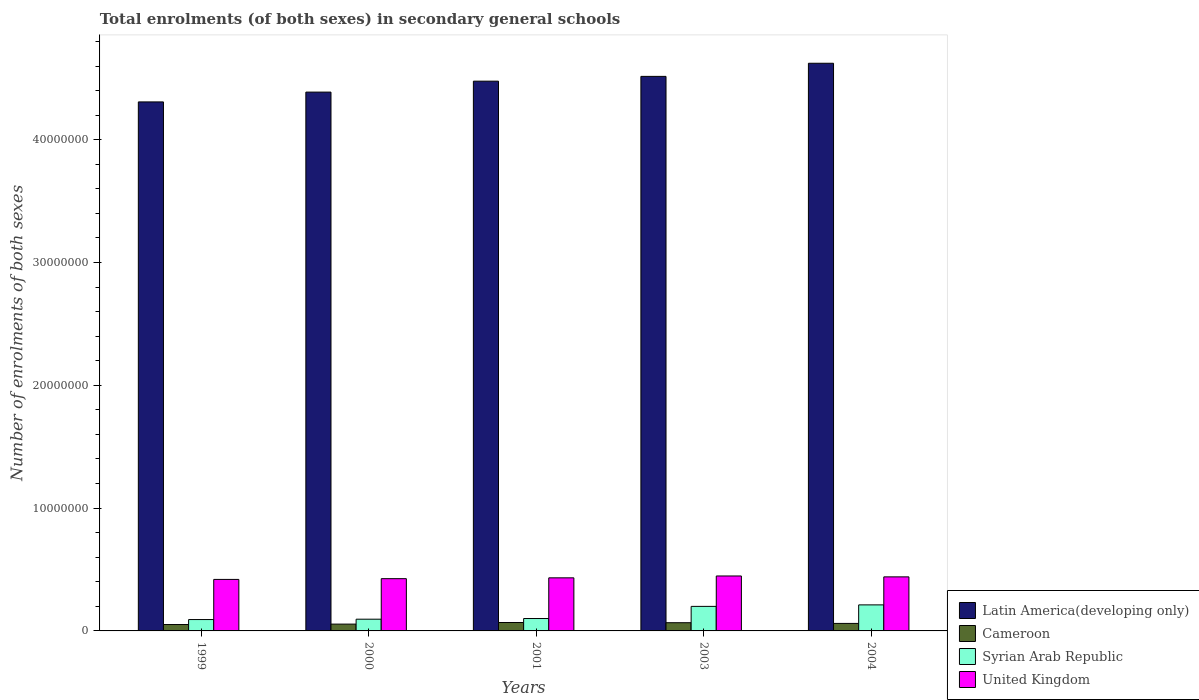How many different coloured bars are there?
Provide a succinct answer. 4. How many groups of bars are there?
Your answer should be compact. 5. Are the number of bars on each tick of the X-axis equal?
Make the answer very short. Yes. How many bars are there on the 3rd tick from the left?
Your response must be concise. 4. How many bars are there on the 2nd tick from the right?
Give a very brief answer. 4. What is the label of the 5th group of bars from the left?
Give a very brief answer. 2004. What is the number of enrolments in secondary schools in Latin America(developing only) in 2000?
Provide a succinct answer. 4.39e+07. Across all years, what is the maximum number of enrolments in secondary schools in Latin America(developing only)?
Offer a very short reply. 4.62e+07. Across all years, what is the minimum number of enrolments in secondary schools in United Kingdom?
Offer a very short reply. 4.19e+06. In which year was the number of enrolments in secondary schools in United Kingdom maximum?
Offer a very short reply. 2003. What is the total number of enrolments in secondary schools in Latin America(developing only) in the graph?
Keep it short and to the point. 2.23e+08. What is the difference between the number of enrolments in secondary schools in Syrian Arab Republic in 2001 and that in 2003?
Your answer should be compact. -9.88e+05. What is the difference between the number of enrolments in secondary schools in Cameroon in 2001 and the number of enrolments in secondary schools in United Kingdom in 2004?
Keep it short and to the point. -3.72e+06. What is the average number of enrolments in secondary schools in Syrian Arab Republic per year?
Your response must be concise. 1.40e+06. In the year 2004, what is the difference between the number of enrolments in secondary schools in Latin America(developing only) and number of enrolments in secondary schools in Syrian Arab Republic?
Offer a terse response. 4.41e+07. What is the ratio of the number of enrolments in secondary schools in Cameroon in 2001 to that in 2003?
Offer a very short reply. 1.02. Is the number of enrolments in secondary schools in Latin America(developing only) in 1999 less than that in 2004?
Give a very brief answer. Yes. What is the difference between the highest and the second highest number of enrolments in secondary schools in Cameroon?
Your answer should be very brief. 1.55e+04. What is the difference between the highest and the lowest number of enrolments in secondary schools in Latin America(developing only)?
Provide a short and direct response. 3.15e+06. What does the 2nd bar from the left in 2004 represents?
Give a very brief answer. Cameroon. What does the 3rd bar from the right in 2000 represents?
Ensure brevity in your answer.  Cameroon. Is it the case that in every year, the sum of the number of enrolments in secondary schools in Latin America(developing only) and number of enrolments in secondary schools in Syrian Arab Republic is greater than the number of enrolments in secondary schools in United Kingdom?
Ensure brevity in your answer.  Yes. How many bars are there?
Offer a very short reply. 20. How many years are there in the graph?
Offer a terse response. 5. What is the difference between two consecutive major ticks on the Y-axis?
Give a very brief answer. 1.00e+07. Are the values on the major ticks of Y-axis written in scientific E-notation?
Provide a short and direct response. No. Does the graph contain any zero values?
Offer a very short reply. No. Does the graph contain grids?
Keep it short and to the point. No. Where does the legend appear in the graph?
Provide a short and direct response. Bottom right. What is the title of the graph?
Make the answer very short. Total enrolments (of both sexes) in secondary general schools. What is the label or title of the X-axis?
Make the answer very short. Years. What is the label or title of the Y-axis?
Your answer should be very brief. Number of enrolments of both sexes. What is the Number of enrolments of both sexes in Latin America(developing only) in 1999?
Give a very brief answer. 4.31e+07. What is the Number of enrolments of both sexes of Cameroon in 1999?
Your answer should be very brief. 5.21e+05. What is the Number of enrolments of both sexes of Syrian Arab Republic in 1999?
Offer a terse response. 9.25e+05. What is the Number of enrolments of both sexes in United Kingdom in 1999?
Give a very brief answer. 4.19e+06. What is the Number of enrolments of both sexes of Latin America(developing only) in 2000?
Your response must be concise. 4.39e+07. What is the Number of enrolments of both sexes of Cameroon in 2000?
Offer a very short reply. 5.55e+05. What is the Number of enrolments of both sexes in Syrian Arab Republic in 2000?
Provide a succinct answer. 9.55e+05. What is the Number of enrolments of both sexes in United Kingdom in 2000?
Your response must be concise. 4.26e+06. What is the Number of enrolments of both sexes in Latin America(developing only) in 2001?
Your answer should be very brief. 4.48e+07. What is the Number of enrolments of both sexes of Cameroon in 2001?
Ensure brevity in your answer.  6.85e+05. What is the Number of enrolments of both sexes in Syrian Arab Republic in 2001?
Your answer should be compact. 1.01e+06. What is the Number of enrolments of both sexes in United Kingdom in 2001?
Provide a short and direct response. 4.32e+06. What is the Number of enrolments of both sexes in Latin America(developing only) in 2003?
Ensure brevity in your answer.  4.52e+07. What is the Number of enrolments of both sexes in Cameroon in 2003?
Provide a short and direct response. 6.69e+05. What is the Number of enrolments of both sexes in Syrian Arab Republic in 2003?
Keep it short and to the point. 2.00e+06. What is the Number of enrolments of both sexes of United Kingdom in 2003?
Your answer should be compact. 4.47e+06. What is the Number of enrolments of both sexes of Latin America(developing only) in 2004?
Offer a very short reply. 4.62e+07. What is the Number of enrolments of both sexes of Cameroon in 2004?
Make the answer very short. 6.12e+05. What is the Number of enrolments of both sexes of Syrian Arab Republic in 2004?
Give a very brief answer. 2.12e+06. What is the Number of enrolments of both sexes of United Kingdom in 2004?
Your answer should be compact. 4.40e+06. Across all years, what is the maximum Number of enrolments of both sexes in Latin America(developing only)?
Your answer should be very brief. 4.62e+07. Across all years, what is the maximum Number of enrolments of both sexes of Cameroon?
Keep it short and to the point. 6.85e+05. Across all years, what is the maximum Number of enrolments of both sexes of Syrian Arab Republic?
Provide a succinct answer. 2.12e+06. Across all years, what is the maximum Number of enrolments of both sexes of United Kingdom?
Keep it short and to the point. 4.47e+06. Across all years, what is the minimum Number of enrolments of both sexes of Latin America(developing only)?
Provide a short and direct response. 4.31e+07. Across all years, what is the minimum Number of enrolments of both sexes of Cameroon?
Keep it short and to the point. 5.21e+05. Across all years, what is the minimum Number of enrolments of both sexes of Syrian Arab Republic?
Your response must be concise. 9.25e+05. Across all years, what is the minimum Number of enrolments of both sexes of United Kingdom?
Offer a very short reply. 4.19e+06. What is the total Number of enrolments of both sexes in Latin America(developing only) in the graph?
Your answer should be compact. 2.23e+08. What is the total Number of enrolments of both sexes of Cameroon in the graph?
Give a very brief answer. 3.04e+06. What is the total Number of enrolments of both sexes in Syrian Arab Republic in the graph?
Your answer should be compact. 7.01e+06. What is the total Number of enrolments of both sexes in United Kingdom in the graph?
Provide a short and direct response. 2.16e+07. What is the difference between the Number of enrolments of both sexes of Latin America(developing only) in 1999 and that in 2000?
Provide a succinct answer. -7.99e+05. What is the difference between the Number of enrolments of both sexes of Cameroon in 1999 and that in 2000?
Your answer should be very brief. -3.42e+04. What is the difference between the Number of enrolments of both sexes of Syrian Arab Republic in 1999 and that in 2000?
Your answer should be compact. -3.00e+04. What is the difference between the Number of enrolments of both sexes of United Kingdom in 1999 and that in 2000?
Your answer should be very brief. -6.19e+04. What is the difference between the Number of enrolments of both sexes in Latin America(developing only) in 1999 and that in 2001?
Your answer should be very brief. -1.69e+06. What is the difference between the Number of enrolments of both sexes of Cameroon in 1999 and that in 2001?
Offer a very short reply. -1.64e+05. What is the difference between the Number of enrolments of both sexes in Syrian Arab Republic in 1999 and that in 2001?
Your answer should be compact. -8.48e+04. What is the difference between the Number of enrolments of both sexes in United Kingdom in 1999 and that in 2001?
Make the answer very short. -1.29e+05. What is the difference between the Number of enrolments of both sexes in Latin America(developing only) in 1999 and that in 2003?
Your answer should be very brief. -2.08e+06. What is the difference between the Number of enrolments of both sexes of Cameroon in 1999 and that in 2003?
Your response must be concise. -1.48e+05. What is the difference between the Number of enrolments of both sexes in Syrian Arab Republic in 1999 and that in 2003?
Offer a very short reply. -1.07e+06. What is the difference between the Number of enrolments of both sexes in United Kingdom in 1999 and that in 2003?
Your answer should be very brief. -2.81e+05. What is the difference between the Number of enrolments of both sexes in Latin America(developing only) in 1999 and that in 2004?
Provide a succinct answer. -3.15e+06. What is the difference between the Number of enrolments of both sexes in Cameroon in 1999 and that in 2004?
Give a very brief answer. -9.10e+04. What is the difference between the Number of enrolments of both sexes of Syrian Arab Republic in 1999 and that in 2004?
Offer a very short reply. -1.20e+06. What is the difference between the Number of enrolments of both sexes of United Kingdom in 1999 and that in 2004?
Offer a terse response. -2.08e+05. What is the difference between the Number of enrolments of both sexes in Latin America(developing only) in 2000 and that in 2001?
Offer a terse response. -8.90e+05. What is the difference between the Number of enrolments of both sexes in Cameroon in 2000 and that in 2001?
Your answer should be very brief. -1.30e+05. What is the difference between the Number of enrolments of both sexes in Syrian Arab Republic in 2000 and that in 2001?
Keep it short and to the point. -5.49e+04. What is the difference between the Number of enrolments of both sexes in United Kingdom in 2000 and that in 2001?
Give a very brief answer. -6.71e+04. What is the difference between the Number of enrolments of both sexes in Latin America(developing only) in 2000 and that in 2003?
Ensure brevity in your answer.  -1.28e+06. What is the difference between the Number of enrolments of both sexes in Cameroon in 2000 and that in 2003?
Provide a succinct answer. -1.14e+05. What is the difference between the Number of enrolments of both sexes in Syrian Arab Republic in 2000 and that in 2003?
Keep it short and to the point. -1.04e+06. What is the difference between the Number of enrolments of both sexes of United Kingdom in 2000 and that in 2003?
Keep it short and to the point. -2.19e+05. What is the difference between the Number of enrolments of both sexes of Latin America(developing only) in 2000 and that in 2004?
Ensure brevity in your answer.  -2.35e+06. What is the difference between the Number of enrolments of both sexes in Cameroon in 2000 and that in 2004?
Offer a terse response. -5.69e+04. What is the difference between the Number of enrolments of both sexes in Syrian Arab Republic in 2000 and that in 2004?
Offer a very short reply. -1.17e+06. What is the difference between the Number of enrolments of both sexes of United Kingdom in 2000 and that in 2004?
Offer a terse response. -1.46e+05. What is the difference between the Number of enrolments of both sexes in Latin America(developing only) in 2001 and that in 2003?
Keep it short and to the point. -3.90e+05. What is the difference between the Number of enrolments of both sexes in Cameroon in 2001 and that in 2003?
Your answer should be very brief. 1.55e+04. What is the difference between the Number of enrolments of both sexes in Syrian Arab Republic in 2001 and that in 2003?
Keep it short and to the point. -9.88e+05. What is the difference between the Number of enrolments of both sexes in United Kingdom in 2001 and that in 2003?
Keep it short and to the point. -1.52e+05. What is the difference between the Number of enrolments of both sexes of Latin America(developing only) in 2001 and that in 2004?
Your answer should be very brief. -1.46e+06. What is the difference between the Number of enrolments of both sexes in Cameroon in 2001 and that in 2004?
Keep it short and to the point. 7.30e+04. What is the difference between the Number of enrolments of both sexes of Syrian Arab Republic in 2001 and that in 2004?
Ensure brevity in your answer.  -1.11e+06. What is the difference between the Number of enrolments of both sexes in United Kingdom in 2001 and that in 2004?
Your response must be concise. -7.89e+04. What is the difference between the Number of enrolments of both sexes of Latin America(developing only) in 2003 and that in 2004?
Your answer should be compact. -1.07e+06. What is the difference between the Number of enrolments of both sexes of Cameroon in 2003 and that in 2004?
Provide a short and direct response. 5.74e+04. What is the difference between the Number of enrolments of both sexes in Syrian Arab Republic in 2003 and that in 2004?
Your answer should be compact. -1.23e+05. What is the difference between the Number of enrolments of both sexes in United Kingdom in 2003 and that in 2004?
Offer a very short reply. 7.30e+04. What is the difference between the Number of enrolments of both sexes in Latin America(developing only) in 1999 and the Number of enrolments of both sexes in Cameroon in 2000?
Offer a very short reply. 4.25e+07. What is the difference between the Number of enrolments of both sexes in Latin America(developing only) in 1999 and the Number of enrolments of both sexes in Syrian Arab Republic in 2000?
Your answer should be compact. 4.21e+07. What is the difference between the Number of enrolments of both sexes of Latin America(developing only) in 1999 and the Number of enrolments of both sexes of United Kingdom in 2000?
Provide a succinct answer. 3.88e+07. What is the difference between the Number of enrolments of both sexes of Cameroon in 1999 and the Number of enrolments of both sexes of Syrian Arab Republic in 2000?
Give a very brief answer. -4.35e+05. What is the difference between the Number of enrolments of both sexes of Cameroon in 1999 and the Number of enrolments of both sexes of United Kingdom in 2000?
Your response must be concise. -3.74e+06. What is the difference between the Number of enrolments of both sexes of Syrian Arab Republic in 1999 and the Number of enrolments of both sexes of United Kingdom in 2000?
Ensure brevity in your answer.  -3.33e+06. What is the difference between the Number of enrolments of both sexes of Latin America(developing only) in 1999 and the Number of enrolments of both sexes of Cameroon in 2001?
Provide a short and direct response. 4.24e+07. What is the difference between the Number of enrolments of both sexes in Latin America(developing only) in 1999 and the Number of enrolments of both sexes in Syrian Arab Republic in 2001?
Your answer should be compact. 4.21e+07. What is the difference between the Number of enrolments of both sexes in Latin America(developing only) in 1999 and the Number of enrolments of both sexes in United Kingdom in 2001?
Ensure brevity in your answer.  3.88e+07. What is the difference between the Number of enrolments of both sexes in Cameroon in 1999 and the Number of enrolments of both sexes in Syrian Arab Republic in 2001?
Offer a terse response. -4.89e+05. What is the difference between the Number of enrolments of both sexes in Cameroon in 1999 and the Number of enrolments of both sexes in United Kingdom in 2001?
Keep it short and to the point. -3.80e+06. What is the difference between the Number of enrolments of both sexes of Syrian Arab Republic in 1999 and the Number of enrolments of both sexes of United Kingdom in 2001?
Make the answer very short. -3.40e+06. What is the difference between the Number of enrolments of both sexes of Latin America(developing only) in 1999 and the Number of enrolments of both sexes of Cameroon in 2003?
Ensure brevity in your answer.  4.24e+07. What is the difference between the Number of enrolments of both sexes in Latin America(developing only) in 1999 and the Number of enrolments of both sexes in Syrian Arab Republic in 2003?
Provide a short and direct response. 4.11e+07. What is the difference between the Number of enrolments of both sexes in Latin America(developing only) in 1999 and the Number of enrolments of both sexes in United Kingdom in 2003?
Your response must be concise. 3.86e+07. What is the difference between the Number of enrolments of both sexes in Cameroon in 1999 and the Number of enrolments of both sexes in Syrian Arab Republic in 2003?
Keep it short and to the point. -1.48e+06. What is the difference between the Number of enrolments of both sexes in Cameroon in 1999 and the Number of enrolments of both sexes in United Kingdom in 2003?
Offer a very short reply. -3.95e+06. What is the difference between the Number of enrolments of both sexes of Syrian Arab Republic in 1999 and the Number of enrolments of both sexes of United Kingdom in 2003?
Your answer should be very brief. -3.55e+06. What is the difference between the Number of enrolments of both sexes of Latin America(developing only) in 1999 and the Number of enrolments of both sexes of Cameroon in 2004?
Give a very brief answer. 4.25e+07. What is the difference between the Number of enrolments of both sexes in Latin America(developing only) in 1999 and the Number of enrolments of both sexes in Syrian Arab Republic in 2004?
Ensure brevity in your answer.  4.10e+07. What is the difference between the Number of enrolments of both sexes of Latin America(developing only) in 1999 and the Number of enrolments of both sexes of United Kingdom in 2004?
Offer a terse response. 3.87e+07. What is the difference between the Number of enrolments of both sexes of Cameroon in 1999 and the Number of enrolments of both sexes of Syrian Arab Republic in 2004?
Keep it short and to the point. -1.60e+06. What is the difference between the Number of enrolments of both sexes of Cameroon in 1999 and the Number of enrolments of both sexes of United Kingdom in 2004?
Keep it short and to the point. -3.88e+06. What is the difference between the Number of enrolments of both sexes of Syrian Arab Republic in 1999 and the Number of enrolments of both sexes of United Kingdom in 2004?
Offer a terse response. -3.48e+06. What is the difference between the Number of enrolments of both sexes of Latin America(developing only) in 2000 and the Number of enrolments of both sexes of Cameroon in 2001?
Keep it short and to the point. 4.32e+07. What is the difference between the Number of enrolments of both sexes in Latin America(developing only) in 2000 and the Number of enrolments of both sexes in Syrian Arab Republic in 2001?
Provide a succinct answer. 4.29e+07. What is the difference between the Number of enrolments of both sexes of Latin America(developing only) in 2000 and the Number of enrolments of both sexes of United Kingdom in 2001?
Offer a terse response. 3.96e+07. What is the difference between the Number of enrolments of both sexes of Cameroon in 2000 and the Number of enrolments of both sexes of Syrian Arab Republic in 2001?
Provide a short and direct response. -4.55e+05. What is the difference between the Number of enrolments of both sexes of Cameroon in 2000 and the Number of enrolments of both sexes of United Kingdom in 2001?
Provide a succinct answer. -3.77e+06. What is the difference between the Number of enrolments of both sexes of Syrian Arab Republic in 2000 and the Number of enrolments of both sexes of United Kingdom in 2001?
Offer a terse response. -3.37e+06. What is the difference between the Number of enrolments of both sexes of Latin America(developing only) in 2000 and the Number of enrolments of both sexes of Cameroon in 2003?
Provide a succinct answer. 4.32e+07. What is the difference between the Number of enrolments of both sexes in Latin America(developing only) in 2000 and the Number of enrolments of both sexes in Syrian Arab Republic in 2003?
Offer a terse response. 4.19e+07. What is the difference between the Number of enrolments of both sexes in Latin America(developing only) in 2000 and the Number of enrolments of both sexes in United Kingdom in 2003?
Make the answer very short. 3.94e+07. What is the difference between the Number of enrolments of both sexes in Cameroon in 2000 and the Number of enrolments of both sexes in Syrian Arab Republic in 2003?
Your answer should be very brief. -1.44e+06. What is the difference between the Number of enrolments of both sexes in Cameroon in 2000 and the Number of enrolments of both sexes in United Kingdom in 2003?
Give a very brief answer. -3.92e+06. What is the difference between the Number of enrolments of both sexes in Syrian Arab Republic in 2000 and the Number of enrolments of both sexes in United Kingdom in 2003?
Make the answer very short. -3.52e+06. What is the difference between the Number of enrolments of both sexes of Latin America(developing only) in 2000 and the Number of enrolments of both sexes of Cameroon in 2004?
Provide a short and direct response. 4.33e+07. What is the difference between the Number of enrolments of both sexes in Latin America(developing only) in 2000 and the Number of enrolments of both sexes in Syrian Arab Republic in 2004?
Make the answer very short. 4.18e+07. What is the difference between the Number of enrolments of both sexes in Latin America(developing only) in 2000 and the Number of enrolments of both sexes in United Kingdom in 2004?
Your answer should be compact. 3.95e+07. What is the difference between the Number of enrolments of both sexes in Cameroon in 2000 and the Number of enrolments of both sexes in Syrian Arab Republic in 2004?
Make the answer very short. -1.57e+06. What is the difference between the Number of enrolments of both sexes of Cameroon in 2000 and the Number of enrolments of both sexes of United Kingdom in 2004?
Keep it short and to the point. -3.85e+06. What is the difference between the Number of enrolments of both sexes in Syrian Arab Republic in 2000 and the Number of enrolments of both sexes in United Kingdom in 2004?
Ensure brevity in your answer.  -3.45e+06. What is the difference between the Number of enrolments of both sexes in Latin America(developing only) in 2001 and the Number of enrolments of both sexes in Cameroon in 2003?
Make the answer very short. 4.41e+07. What is the difference between the Number of enrolments of both sexes of Latin America(developing only) in 2001 and the Number of enrolments of both sexes of Syrian Arab Republic in 2003?
Offer a very short reply. 4.28e+07. What is the difference between the Number of enrolments of both sexes in Latin America(developing only) in 2001 and the Number of enrolments of both sexes in United Kingdom in 2003?
Provide a short and direct response. 4.03e+07. What is the difference between the Number of enrolments of both sexes in Cameroon in 2001 and the Number of enrolments of both sexes in Syrian Arab Republic in 2003?
Ensure brevity in your answer.  -1.31e+06. What is the difference between the Number of enrolments of both sexes in Cameroon in 2001 and the Number of enrolments of both sexes in United Kingdom in 2003?
Ensure brevity in your answer.  -3.79e+06. What is the difference between the Number of enrolments of both sexes of Syrian Arab Republic in 2001 and the Number of enrolments of both sexes of United Kingdom in 2003?
Provide a short and direct response. -3.46e+06. What is the difference between the Number of enrolments of both sexes in Latin America(developing only) in 2001 and the Number of enrolments of both sexes in Cameroon in 2004?
Offer a terse response. 4.42e+07. What is the difference between the Number of enrolments of both sexes of Latin America(developing only) in 2001 and the Number of enrolments of both sexes of Syrian Arab Republic in 2004?
Provide a succinct answer. 4.26e+07. What is the difference between the Number of enrolments of both sexes of Latin America(developing only) in 2001 and the Number of enrolments of both sexes of United Kingdom in 2004?
Your answer should be very brief. 4.04e+07. What is the difference between the Number of enrolments of both sexes in Cameroon in 2001 and the Number of enrolments of both sexes in Syrian Arab Republic in 2004?
Give a very brief answer. -1.44e+06. What is the difference between the Number of enrolments of both sexes in Cameroon in 2001 and the Number of enrolments of both sexes in United Kingdom in 2004?
Your answer should be compact. -3.72e+06. What is the difference between the Number of enrolments of both sexes of Syrian Arab Republic in 2001 and the Number of enrolments of both sexes of United Kingdom in 2004?
Your answer should be very brief. -3.39e+06. What is the difference between the Number of enrolments of both sexes in Latin America(developing only) in 2003 and the Number of enrolments of both sexes in Cameroon in 2004?
Your answer should be very brief. 4.45e+07. What is the difference between the Number of enrolments of both sexes in Latin America(developing only) in 2003 and the Number of enrolments of both sexes in Syrian Arab Republic in 2004?
Your response must be concise. 4.30e+07. What is the difference between the Number of enrolments of both sexes of Latin America(developing only) in 2003 and the Number of enrolments of both sexes of United Kingdom in 2004?
Your response must be concise. 4.08e+07. What is the difference between the Number of enrolments of both sexes of Cameroon in 2003 and the Number of enrolments of both sexes of Syrian Arab Republic in 2004?
Give a very brief answer. -1.45e+06. What is the difference between the Number of enrolments of both sexes in Cameroon in 2003 and the Number of enrolments of both sexes in United Kingdom in 2004?
Ensure brevity in your answer.  -3.73e+06. What is the difference between the Number of enrolments of both sexes in Syrian Arab Republic in 2003 and the Number of enrolments of both sexes in United Kingdom in 2004?
Your answer should be compact. -2.40e+06. What is the average Number of enrolments of both sexes in Latin America(developing only) per year?
Ensure brevity in your answer.  4.46e+07. What is the average Number of enrolments of both sexes in Cameroon per year?
Your answer should be very brief. 6.08e+05. What is the average Number of enrolments of both sexes of Syrian Arab Republic per year?
Your response must be concise. 1.40e+06. What is the average Number of enrolments of both sexes in United Kingdom per year?
Make the answer very short. 4.33e+06. In the year 1999, what is the difference between the Number of enrolments of both sexes in Latin America(developing only) and Number of enrolments of both sexes in Cameroon?
Keep it short and to the point. 4.26e+07. In the year 1999, what is the difference between the Number of enrolments of both sexes in Latin America(developing only) and Number of enrolments of both sexes in Syrian Arab Republic?
Offer a very short reply. 4.22e+07. In the year 1999, what is the difference between the Number of enrolments of both sexes of Latin America(developing only) and Number of enrolments of both sexes of United Kingdom?
Keep it short and to the point. 3.89e+07. In the year 1999, what is the difference between the Number of enrolments of both sexes of Cameroon and Number of enrolments of both sexes of Syrian Arab Republic?
Keep it short and to the point. -4.05e+05. In the year 1999, what is the difference between the Number of enrolments of both sexes in Cameroon and Number of enrolments of both sexes in United Kingdom?
Your answer should be very brief. -3.67e+06. In the year 1999, what is the difference between the Number of enrolments of both sexes of Syrian Arab Republic and Number of enrolments of both sexes of United Kingdom?
Provide a succinct answer. -3.27e+06. In the year 2000, what is the difference between the Number of enrolments of both sexes in Latin America(developing only) and Number of enrolments of both sexes in Cameroon?
Ensure brevity in your answer.  4.33e+07. In the year 2000, what is the difference between the Number of enrolments of both sexes in Latin America(developing only) and Number of enrolments of both sexes in Syrian Arab Republic?
Your answer should be compact. 4.29e+07. In the year 2000, what is the difference between the Number of enrolments of both sexes in Latin America(developing only) and Number of enrolments of both sexes in United Kingdom?
Offer a terse response. 3.96e+07. In the year 2000, what is the difference between the Number of enrolments of both sexes in Cameroon and Number of enrolments of both sexes in Syrian Arab Republic?
Provide a short and direct response. -4.00e+05. In the year 2000, what is the difference between the Number of enrolments of both sexes of Cameroon and Number of enrolments of both sexes of United Kingdom?
Keep it short and to the point. -3.70e+06. In the year 2000, what is the difference between the Number of enrolments of both sexes of Syrian Arab Republic and Number of enrolments of both sexes of United Kingdom?
Your response must be concise. -3.30e+06. In the year 2001, what is the difference between the Number of enrolments of both sexes of Latin America(developing only) and Number of enrolments of both sexes of Cameroon?
Provide a short and direct response. 4.41e+07. In the year 2001, what is the difference between the Number of enrolments of both sexes in Latin America(developing only) and Number of enrolments of both sexes in Syrian Arab Republic?
Offer a very short reply. 4.38e+07. In the year 2001, what is the difference between the Number of enrolments of both sexes in Latin America(developing only) and Number of enrolments of both sexes in United Kingdom?
Give a very brief answer. 4.04e+07. In the year 2001, what is the difference between the Number of enrolments of both sexes in Cameroon and Number of enrolments of both sexes in Syrian Arab Republic?
Provide a succinct answer. -3.26e+05. In the year 2001, what is the difference between the Number of enrolments of both sexes of Cameroon and Number of enrolments of both sexes of United Kingdom?
Your response must be concise. -3.64e+06. In the year 2001, what is the difference between the Number of enrolments of both sexes of Syrian Arab Republic and Number of enrolments of both sexes of United Kingdom?
Keep it short and to the point. -3.31e+06. In the year 2003, what is the difference between the Number of enrolments of both sexes of Latin America(developing only) and Number of enrolments of both sexes of Cameroon?
Your answer should be compact. 4.45e+07. In the year 2003, what is the difference between the Number of enrolments of both sexes of Latin America(developing only) and Number of enrolments of both sexes of Syrian Arab Republic?
Your response must be concise. 4.32e+07. In the year 2003, what is the difference between the Number of enrolments of both sexes in Latin America(developing only) and Number of enrolments of both sexes in United Kingdom?
Your answer should be very brief. 4.07e+07. In the year 2003, what is the difference between the Number of enrolments of both sexes of Cameroon and Number of enrolments of both sexes of Syrian Arab Republic?
Provide a short and direct response. -1.33e+06. In the year 2003, what is the difference between the Number of enrolments of both sexes in Cameroon and Number of enrolments of both sexes in United Kingdom?
Provide a short and direct response. -3.81e+06. In the year 2003, what is the difference between the Number of enrolments of both sexes in Syrian Arab Republic and Number of enrolments of both sexes in United Kingdom?
Give a very brief answer. -2.48e+06. In the year 2004, what is the difference between the Number of enrolments of both sexes of Latin America(developing only) and Number of enrolments of both sexes of Cameroon?
Make the answer very short. 4.56e+07. In the year 2004, what is the difference between the Number of enrolments of both sexes of Latin America(developing only) and Number of enrolments of both sexes of Syrian Arab Republic?
Your answer should be compact. 4.41e+07. In the year 2004, what is the difference between the Number of enrolments of both sexes in Latin America(developing only) and Number of enrolments of both sexes in United Kingdom?
Ensure brevity in your answer.  4.18e+07. In the year 2004, what is the difference between the Number of enrolments of both sexes in Cameroon and Number of enrolments of both sexes in Syrian Arab Republic?
Ensure brevity in your answer.  -1.51e+06. In the year 2004, what is the difference between the Number of enrolments of both sexes in Cameroon and Number of enrolments of both sexes in United Kingdom?
Offer a terse response. -3.79e+06. In the year 2004, what is the difference between the Number of enrolments of both sexes of Syrian Arab Republic and Number of enrolments of both sexes of United Kingdom?
Keep it short and to the point. -2.28e+06. What is the ratio of the Number of enrolments of both sexes in Latin America(developing only) in 1999 to that in 2000?
Give a very brief answer. 0.98. What is the ratio of the Number of enrolments of both sexes in Cameroon in 1999 to that in 2000?
Provide a succinct answer. 0.94. What is the ratio of the Number of enrolments of both sexes of Syrian Arab Republic in 1999 to that in 2000?
Keep it short and to the point. 0.97. What is the ratio of the Number of enrolments of both sexes in United Kingdom in 1999 to that in 2000?
Provide a short and direct response. 0.99. What is the ratio of the Number of enrolments of both sexes in Latin America(developing only) in 1999 to that in 2001?
Your response must be concise. 0.96. What is the ratio of the Number of enrolments of both sexes in Cameroon in 1999 to that in 2001?
Keep it short and to the point. 0.76. What is the ratio of the Number of enrolments of both sexes in Syrian Arab Republic in 1999 to that in 2001?
Make the answer very short. 0.92. What is the ratio of the Number of enrolments of both sexes of United Kingdom in 1999 to that in 2001?
Make the answer very short. 0.97. What is the ratio of the Number of enrolments of both sexes in Latin America(developing only) in 1999 to that in 2003?
Provide a succinct answer. 0.95. What is the ratio of the Number of enrolments of both sexes in Cameroon in 1999 to that in 2003?
Ensure brevity in your answer.  0.78. What is the ratio of the Number of enrolments of both sexes in Syrian Arab Republic in 1999 to that in 2003?
Give a very brief answer. 0.46. What is the ratio of the Number of enrolments of both sexes in United Kingdom in 1999 to that in 2003?
Ensure brevity in your answer.  0.94. What is the ratio of the Number of enrolments of both sexes in Latin America(developing only) in 1999 to that in 2004?
Offer a terse response. 0.93. What is the ratio of the Number of enrolments of both sexes in Cameroon in 1999 to that in 2004?
Your answer should be compact. 0.85. What is the ratio of the Number of enrolments of both sexes of Syrian Arab Republic in 1999 to that in 2004?
Offer a terse response. 0.44. What is the ratio of the Number of enrolments of both sexes of United Kingdom in 1999 to that in 2004?
Offer a terse response. 0.95. What is the ratio of the Number of enrolments of both sexes of Latin America(developing only) in 2000 to that in 2001?
Your answer should be compact. 0.98. What is the ratio of the Number of enrolments of both sexes of Cameroon in 2000 to that in 2001?
Ensure brevity in your answer.  0.81. What is the ratio of the Number of enrolments of both sexes of Syrian Arab Republic in 2000 to that in 2001?
Ensure brevity in your answer.  0.95. What is the ratio of the Number of enrolments of both sexes of United Kingdom in 2000 to that in 2001?
Make the answer very short. 0.98. What is the ratio of the Number of enrolments of both sexes in Latin America(developing only) in 2000 to that in 2003?
Provide a short and direct response. 0.97. What is the ratio of the Number of enrolments of both sexes in Cameroon in 2000 to that in 2003?
Your answer should be compact. 0.83. What is the ratio of the Number of enrolments of both sexes in Syrian Arab Republic in 2000 to that in 2003?
Provide a succinct answer. 0.48. What is the ratio of the Number of enrolments of both sexes in United Kingdom in 2000 to that in 2003?
Ensure brevity in your answer.  0.95. What is the ratio of the Number of enrolments of both sexes of Latin America(developing only) in 2000 to that in 2004?
Provide a short and direct response. 0.95. What is the ratio of the Number of enrolments of both sexes in Cameroon in 2000 to that in 2004?
Make the answer very short. 0.91. What is the ratio of the Number of enrolments of both sexes of Syrian Arab Republic in 2000 to that in 2004?
Provide a succinct answer. 0.45. What is the ratio of the Number of enrolments of both sexes of United Kingdom in 2000 to that in 2004?
Provide a succinct answer. 0.97. What is the ratio of the Number of enrolments of both sexes of Cameroon in 2001 to that in 2003?
Make the answer very short. 1.02. What is the ratio of the Number of enrolments of both sexes in Syrian Arab Republic in 2001 to that in 2003?
Your response must be concise. 0.51. What is the ratio of the Number of enrolments of both sexes of United Kingdom in 2001 to that in 2003?
Offer a very short reply. 0.97. What is the ratio of the Number of enrolments of both sexes of Latin America(developing only) in 2001 to that in 2004?
Your answer should be very brief. 0.97. What is the ratio of the Number of enrolments of both sexes of Cameroon in 2001 to that in 2004?
Offer a terse response. 1.12. What is the ratio of the Number of enrolments of both sexes in Syrian Arab Republic in 2001 to that in 2004?
Keep it short and to the point. 0.48. What is the ratio of the Number of enrolments of both sexes in United Kingdom in 2001 to that in 2004?
Ensure brevity in your answer.  0.98. What is the ratio of the Number of enrolments of both sexes in Latin America(developing only) in 2003 to that in 2004?
Make the answer very short. 0.98. What is the ratio of the Number of enrolments of both sexes of Cameroon in 2003 to that in 2004?
Make the answer very short. 1.09. What is the ratio of the Number of enrolments of both sexes of Syrian Arab Republic in 2003 to that in 2004?
Your response must be concise. 0.94. What is the ratio of the Number of enrolments of both sexes of United Kingdom in 2003 to that in 2004?
Your response must be concise. 1.02. What is the difference between the highest and the second highest Number of enrolments of both sexes in Latin America(developing only)?
Your answer should be compact. 1.07e+06. What is the difference between the highest and the second highest Number of enrolments of both sexes in Cameroon?
Keep it short and to the point. 1.55e+04. What is the difference between the highest and the second highest Number of enrolments of both sexes of Syrian Arab Republic?
Offer a very short reply. 1.23e+05. What is the difference between the highest and the second highest Number of enrolments of both sexes in United Kingdom?
Your response must be concise. 7.30e+04. What is the difference between the highest and the lowest Number of enrolments of both sexes in Latin America(developing only)?
Your answer should be compact. 3.15e+06. What is the difference between the highest and the lowest Number of enrolments of both sexes in Cameroon?
Your answer should be very brief. 1.64e+05. What is the difference between the highest and the lowest Number of enrolments of both sexes of Syrian Arab Republic?
Offer a very short reply. 1.20e+06. What is the difference between the highest and the lowest Number of enrolments of both sexes in United Kingdom?
Offer a terse response. 2.81e+05. 